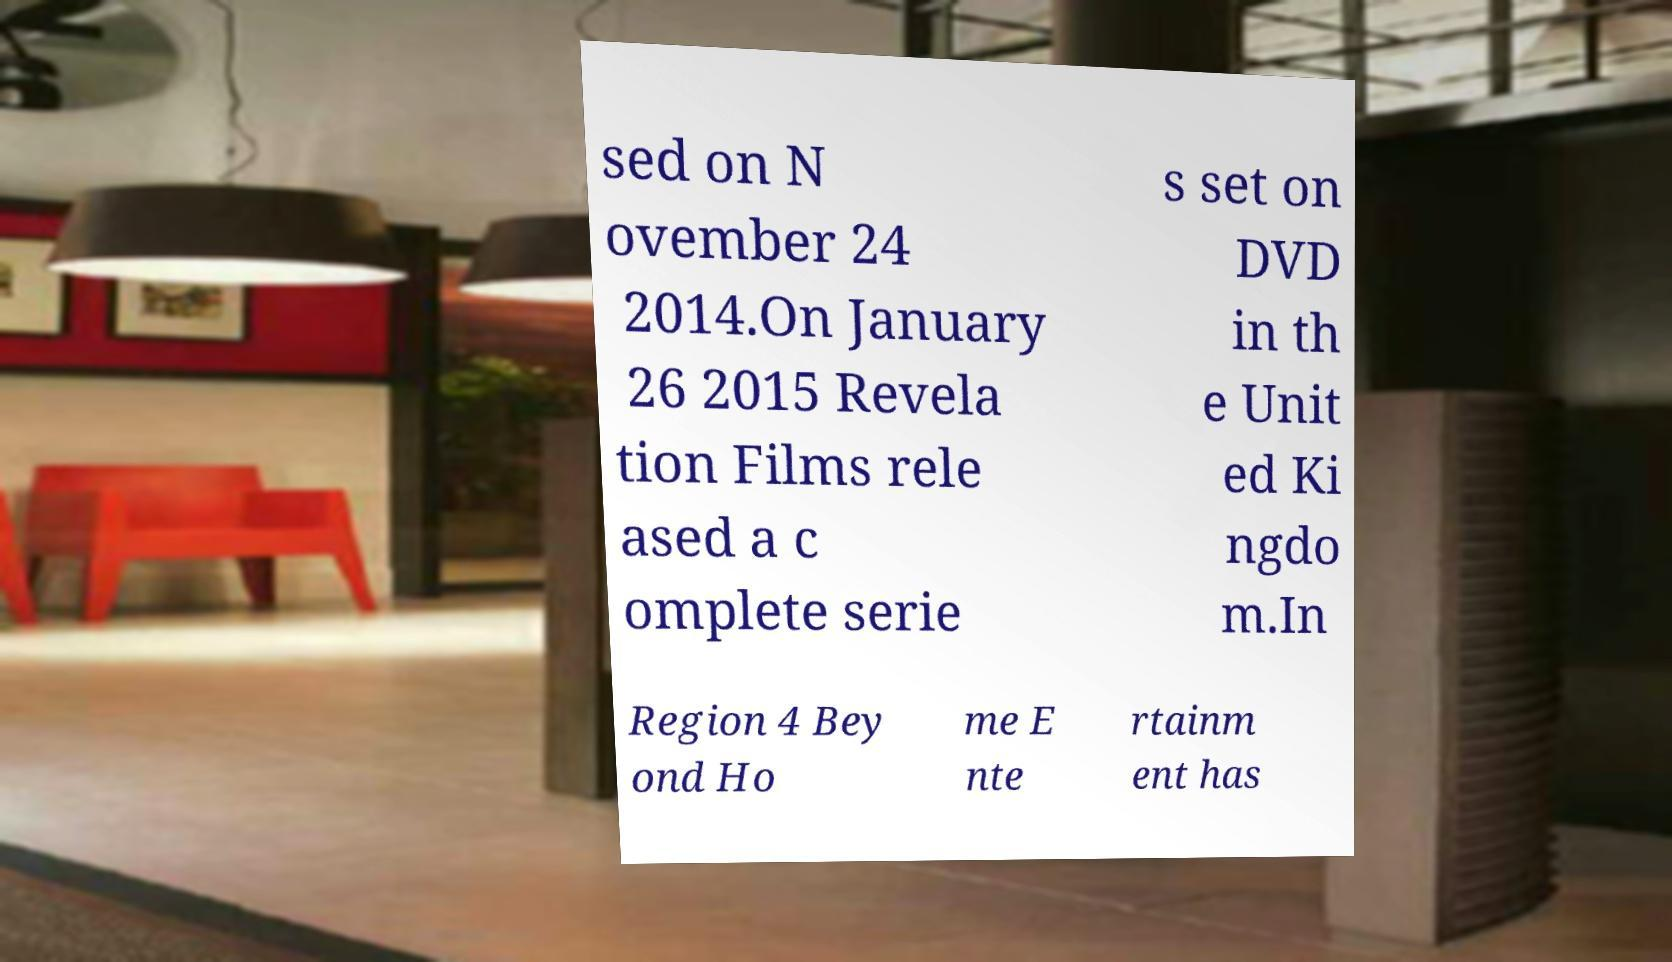For documentation purposes, I need the text within this image transcribed. Could you provide that? sed on N ovember 24 2014.On January 26 2015 Revela tion Films rele ased a c omplete serie s set on DVD in th e Unit ed Ki ngdo m.In Region 4 Bey ond Ho me E nte rtainm ent has 